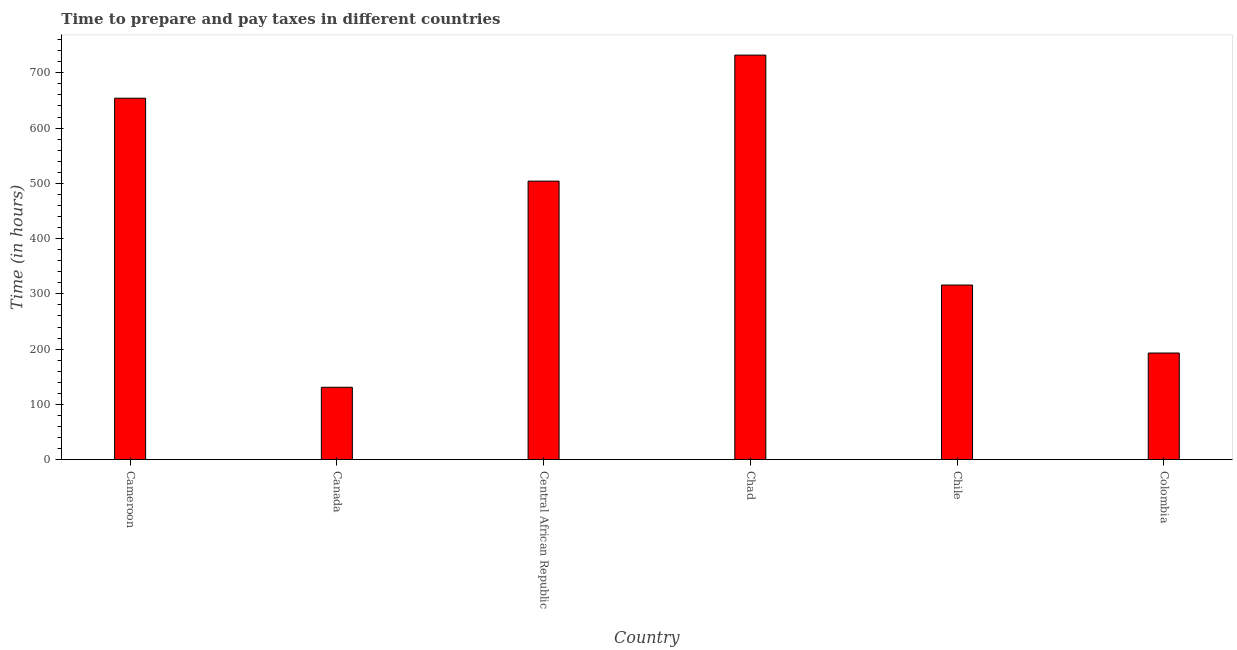Does the graph contain any zero values?
Provide a succinct answer. No. What is the title of the graph?
Provide a short and direct response. Time to prepare and pay taxes in different countries. What is the label or title of the Y-axis?
Your answer should be compact. Time (in hours). What is the time to prepare and pay taxes in Chile?
Your answer should be very brief. 316. Across all countries, what is the maximum time to prepare and pay taxes?
Keep it short and to the point. 732. Across all countries, what is the minimum time to prepare and pay taxes?
Provide a short and direct response. 131. In which country was the time to prepare and pay taxes maximum?
Provide a succinct answer. Chad. In which country was the time to prepare and pay taxes minimum?
Provide a short and direct response. Canada. What is the sum of the time to prepare and pay taxes?
Provide a short and direct response. 2530. What is the difference between the time to prepare and pay taxes in Chad and Colombia?
Provide a succinct answer. 539. What is the average time to prepare and pay taxes per country?
Offer a terse response. 421.67. What is the median time to prepare and pay taxes?
Keep it short and to the point. 410. In how many countries, is the time to prepare and pay taxes greater than 580 hours?
Provide a succinct answer. 2. What is the ratio of the time to prepare and pay taxes in Chad to that in Chile?
Your answer should be compact. 2.32. Is the difference between the time to prepare and pay taxes in Cameroon and Canada greater than the difference between any two countries?
Keep it short and to the point. No. What is the difference between the highest and the second highest time to prepare and pay taxes?
Provide a succinct answer. 78. Is the sum of the time to prepare and pay taxes in Canada and Central African Republic greater than the maximum time to prepare and pay taxes across all countries?
Your response must be concise. No. What is the difference between the highest and the lowest time to prepare and pay taxes?
Offer a very short reply. 601. Are all the bars in the graph horizontal?
Ensure brevity in your answer.  No. How many countries are there in the graph?
Your answer should be very brief. 6. What is the difference between two consecutive major ticks on the Y-axis?
Give a very brief answer. 100. Are the values on the major ticks of Y-axis written in scientific E-notation?
Make the answer very short. No. What is the Time (in hours) in Cameroon?
Your answer should be very brief. 654. What is the Time (in hours) in Canada?
Give a very brief answer. 131. What is the Time (in hours) in Central African Republic?
Provide a short and direct response. 504. What is the Time (in hours) of Chad?
Provide a succinct answer. 732. What is the Time (in hours) of Chile?
Make the answer very short. 316. What is the Time (in hours) of Colombia?
Provide a short and direct response. 193. What is the difference between the Time (in hours) in Cameroon and Canada?
Provide a succinct answer. 523. What is the difference between the Time (in hours) in Cameroon and Central African Republic?
Provide a short and direct response. 150. What is the difference between the Time (in hours) in Cameroon and Chad?
Your response must be concise. -78. What is the difference between the Time (in hours) in Cameroon and Chile?
Make the answer very short. 338. What is the difference between the Time (in hours) in Cameroon and Colombia?
Give a very brief answer. 461. What is the difference between the Time (in hours) in Canada and Central African Republic?
Give a very brief answer. -373. What is the difference between the Time (in hours) in Canada and Chad?
Ensure brevity in your answer.  -601. What is the difference between the Time (in hours) in Canada and Chile?
Keep it short and to the point. -185. What is the difference between the Time (in hours) in Canada and Colombia?
Provide a short and direct response. -62. What is the difference between the Time (in hours) in Central African Republic and Chad?
Provide a succinct answer. -228. What is the difference between the Time (in hours) in Central African Republic and Chile?
Give a very brief answer. 188. What is the difference between the Time (in hours) in Central African Republic and Colombia?
Your answer should be compact. 311. What is the difference between the Time (in hours) in Chad and Chile?
Your answer should be very brief. 416. What is the difference between the Time (in hours) in Chad and Colombia?
Make the answer very short. 539. What is the difference between the Time (in hours) in Chile and Colombia?
Your answer should be very brief. 123. What is the ratio of the Time (in hours) in Cameroon to that in Canada?
Give a very brief answer. 4.99. What is the ratio of the Time (in hours) in Cameroon to that in Central African Republic?
Your answer should be compact. 1.3. What is the ratio of the Time (in hours) in Cameroon to that in Chad?
Make the answer very short. 0.89. What is the ratio of the Time (in hours) in Cameroon to that in Chile?
Give a very brief answer. 2.07. What is the ratio of the Time (in hours) in Cameroon to that in Colombia?
Keep it short and to the point. 3.39. What is the ratio of the Time (in hours) in Canada to that in Central African Republic?
Ensure brevity in your answer.  0.26. What is the ratio of the Time (in hours) in Canada to that in Chad?
Keep it short and to the point. 0.18. What is the ratio of the Time (in hours) in Canada to that in Chile?
Offer a very short reply. 0.41. What is the ratio of the Time (in hours) in Canada to that in Colombia?
Provide a short and direct response. 0.68. What is the ratio of the Time (in hours) in Central African Republic to that in Chad?
Your response must be concise. 0.69. What is the ratio of the Time (in hours) in Central African Republic to that in Chile?
Offer a very short reply. 1.59. What is the ratio of the Time (in hours) in Central African Republic to that in Colombia?
Your response must be concise. 2.61. What is the ratio of the Time (in hours) in Chad to that in Chile?
Your answer should be compact. 2.32. What is the ratio of the Time (in hours) in Chad to that in Colombia?
Offer a terse response. 3.79. What is the ratio of the Time (in hours) in Chile to that in Colombia?
Your answer should be very brief. 1.64. 